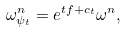Convert formula to latex. <formula><loc_0><loc_0><loc_500><loc_500>\omega _ { \psi _ { t } } ^ { n } = e ^ { t f + c _ { t } } \omega ^ { n } ,</formula> 